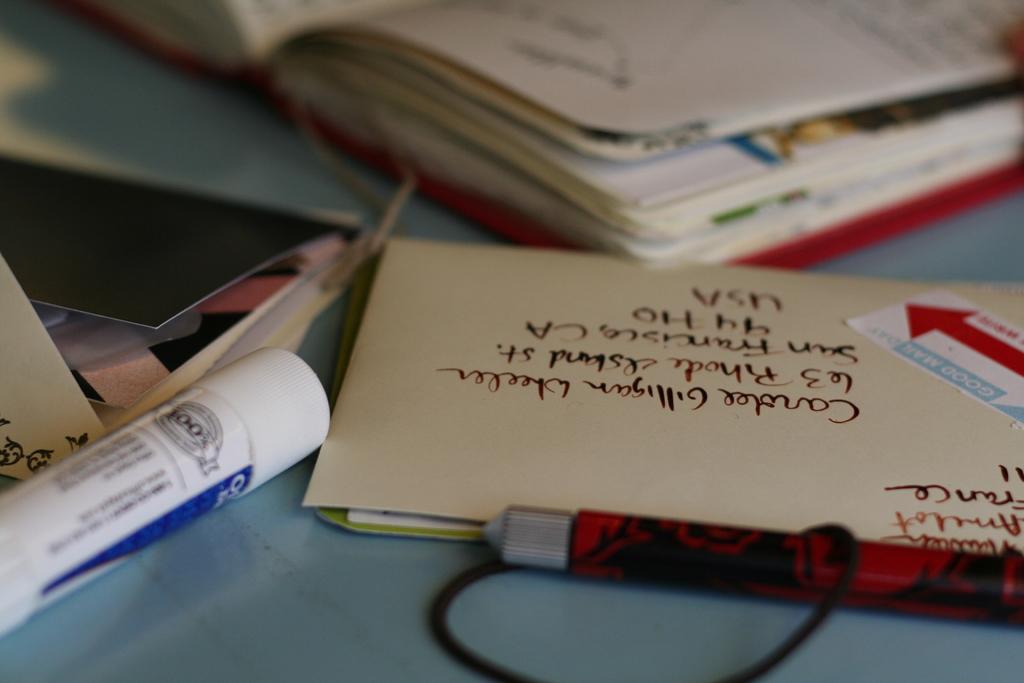What country is the letter from ?
Make the answer very short. Usa. Who's name is on the envelope?
Offer a very short reply. Carolee gilligan wheeler. 